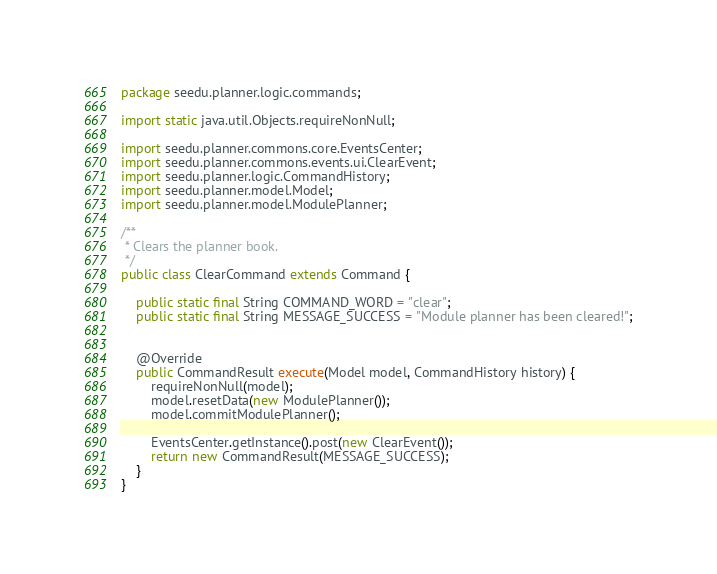Convert code to text. <code><loc_0><loc_0><loc_500><loc_500><_Java_>package seedu.planner.logic.commands;

import static java.util.Objects.requireNonNull;

import seedu.planner.commons.core.EventsCenter;
import seedu.planner.commons.events.ui.ClearEvent;
import seedu.planner.logic.CommandHistory;
import seedu.planner.model.Model;
import seedu.planner.model.ModulePlanner;

/**
 * Clears the planner book.
 */
public class ClearCommand extends Command {

    public static final String COMMAND_WORD = "clear";
    public static final String MESSAGE_SUCCESS = "Module planner has been cleared!";


    @Override
    public CommandResult execute(Model model, CommandHistory history) {
        requireNonNull(model);
        model.resetData(new ModulePlanner());
        model.commitModulePlanner();

        EventsCenter.getInstance().post(new ClearEvent());
        return new CommandResult(MESSAGE_SUCCESS);
    }
}
</code> 